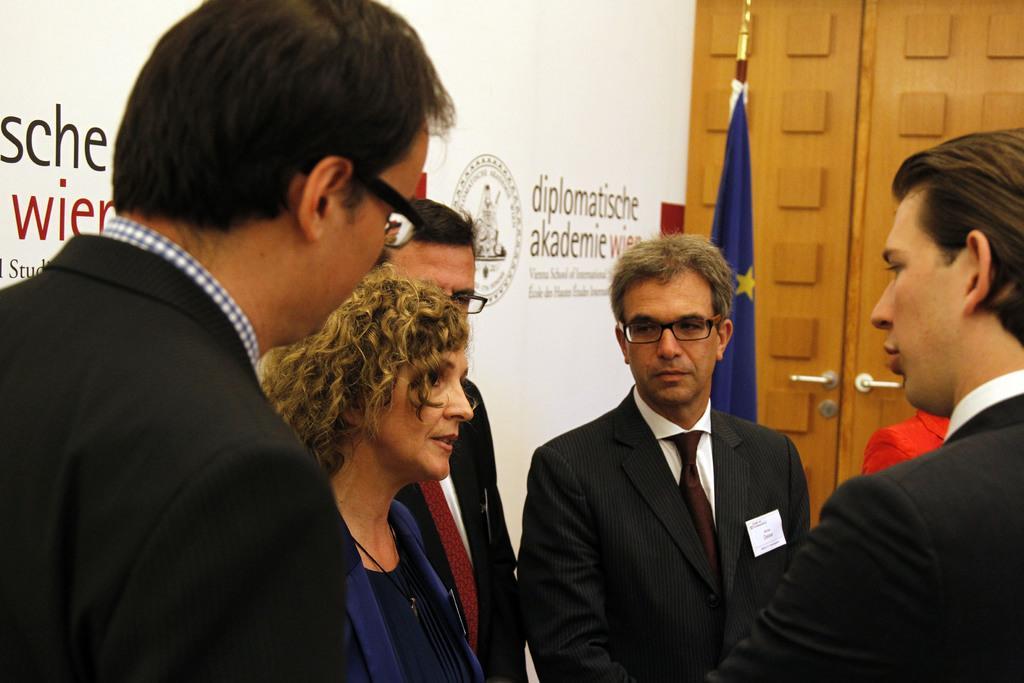Describe this image in one or two sentences. In this image we can see there are so many people standing in group behind them there is a pole with flag and banner at the back. 